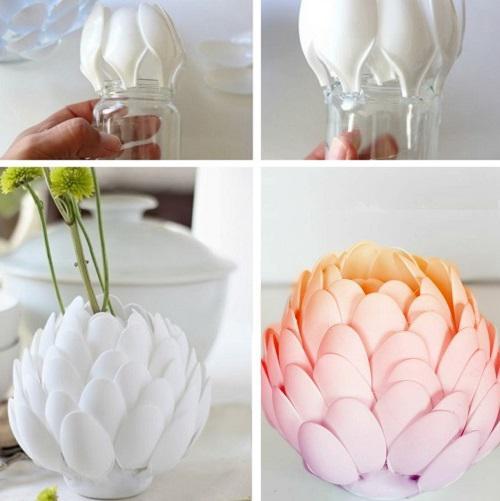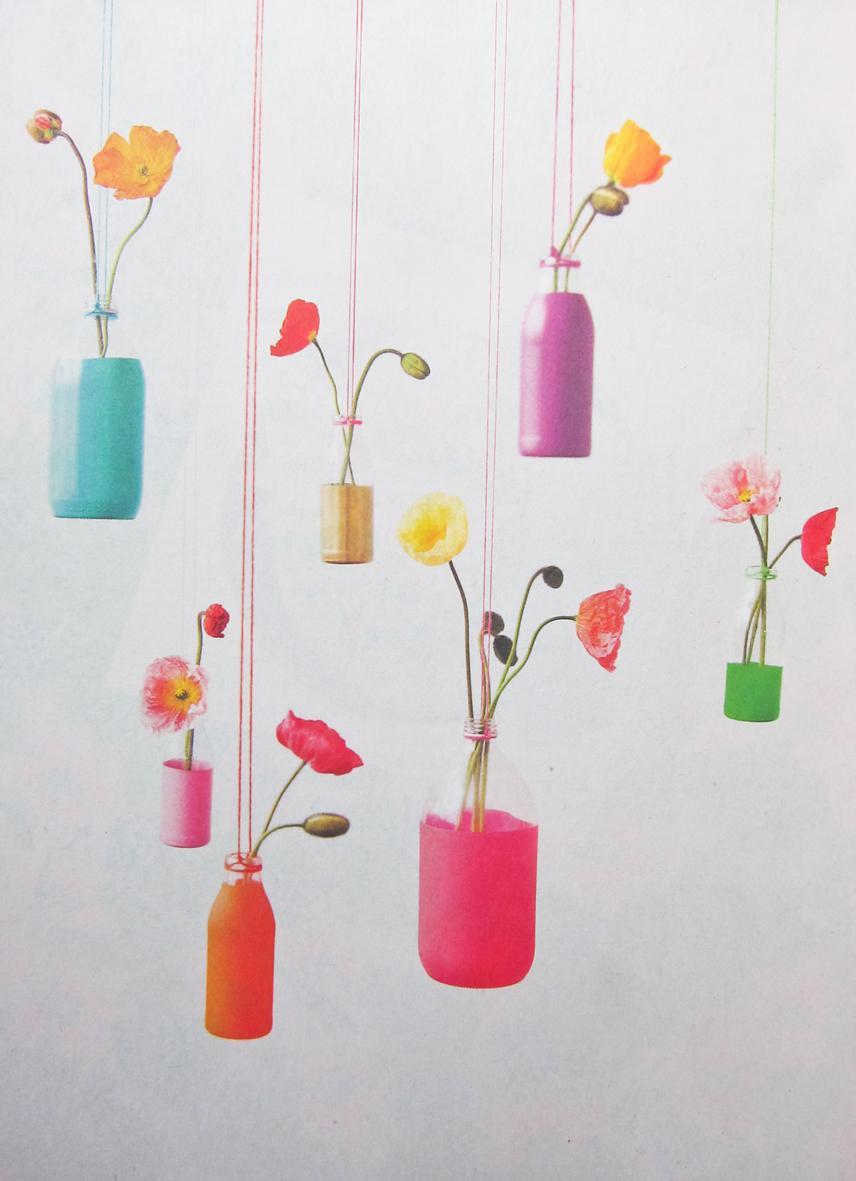The first image is the image on the left, the second image is the image on the right. Assess this claim about the two images: "There is a plant in a blue vase.". Correct or not? Answer yes or no. Yes. 